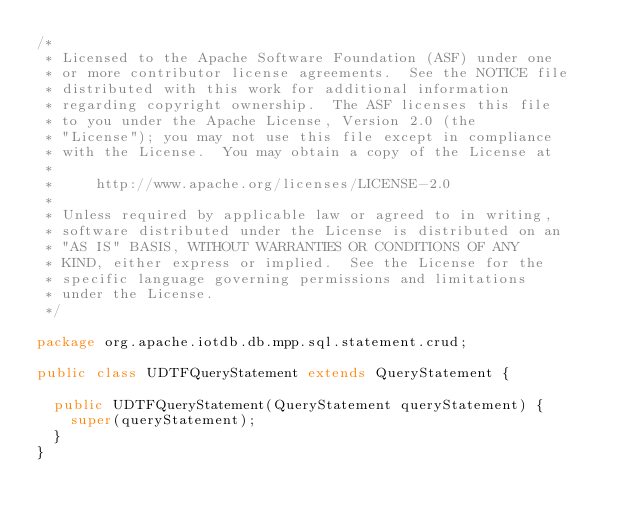<code> <loc_0><loc_0><loc_500><loc_500><_Java_>/*
 * Licensed to the Apache Software Foundation (ASF) under one
 * or more contributor license agreements.  See the NOTICE file
 * distributed with this work for additional information
 * regarding copyright ownership.  The ASF licenses this file
 * to you under the Apache License, Version 2.0 (the
 * "License"); you may not use this file except in compliance
 * with the License.  You may obtain a copy of the License at
 *
 *     http://www.apache.org/licenses/LICENSE-2.0
 *
 * Unless required by applicable law or agreed to in writing,
 * software distributed under the License is distributed on an
 * "AS IS" BASIS, WITHOUT WARRANTIES OR CONDITIONS OF ANY
 * KIND, either express or implied.  See the License for the
 * specific language governing permissions and limitations
 * under the License.
 */

package org.apache.iotdb.db.mpp.sql.statement.crud;

public class UDTFQueryStatement extends QueryStatement {

  public UDTFQueryStatement(QueryStatement queryStatement) {
    super(queryStatement);
  }
}
</code> 